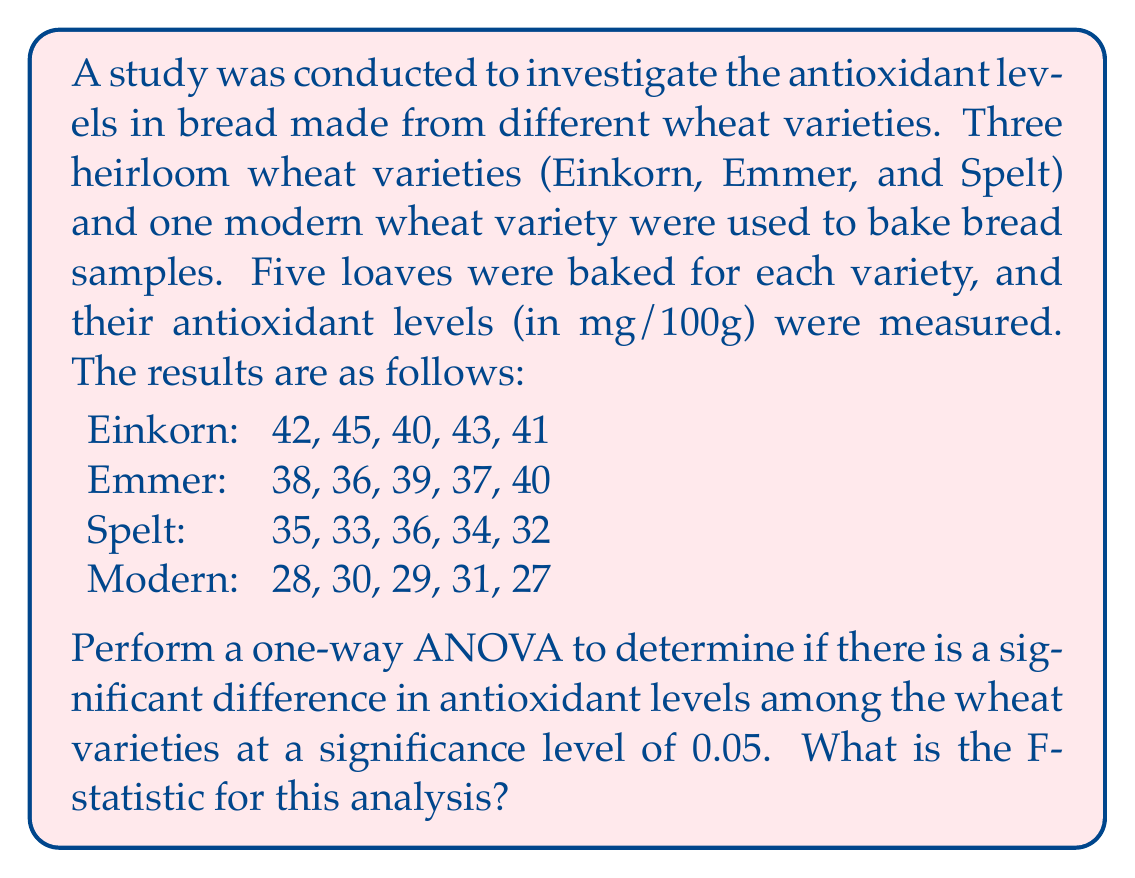Solve this math problem. To perform a one-way ANOVA, we need to follow these steps:

1. Calculate the sum of squares between groups (SSB) and within groups (SSW).
2. Calculate the degrees of freedom between groups (dfB) and within groups (dfW).
3. Calculate the mean square between groups (MSB) and within groups (MSW).
4. Calculate the F-statistic.

Step 1: Calculate SSB and SSW

First, we need to calculate the grand mean and group means:

Grand mean: $\bar{X} = \frac{(42+45+40+43+41+38+36+39+37+40+35+33+36+34+32+28+30+29+31+27)}{20} = 35.8$

Group means:
Einkorn: $\bar{X}_1 = 42.2$
Emmer: $\bar{X}_2 = 38$
Spelt: $\bar{X}_3 = 34$
Modern: $\bar{X}_4 = 29$

Now, we can calculate SSB:

$$SSB = \sum_{i=1}^k n_i(\bar{X}_i - \bar{X})^2$$

Where $k$ is the number of groups (4) and $n_i$ is the number of samples in each group (5).

$$SSB = 5(42.2 - 35.8)^2 + 5(38 - 35.8)^2 + 5(34 - 35.8)^2 + 5(29 - 35.8)^2 = 522.2$$

For SSW, we calculate:

$$SSW = \sum_{i=1}^k \sum_{j=1}^{n_i} (X_{ij} - \bar{X}_i)^2$$

$$SSW = [(42-42.2)^2 + (45-42.2)^2 + ... + (27-29)^2] = 70.8$$

Step 2: Calculate degrees of freedom

$$dfB = k - 1 = 4 - 1 = 3$$
$$dfW = N - k = 20 - 4 = 16$$

Where $N$ is the total number of samples.

Step 3: Calculate mean squares

$$MSB = \frac{SSB}{dfB} = \frac{522.2}{3} = 174.067$$
$$MSW = \frac{SSW}{dfW} = \frac{70.8}{16} = 4.425$$

Step 4: Calculate F-statistic

$$F = \frac{MSB}{MSW} = \frac{174.067}{4.425} = 39.337$$
Answer: The F-statistic for this one-way ANOVA is 39.337. 